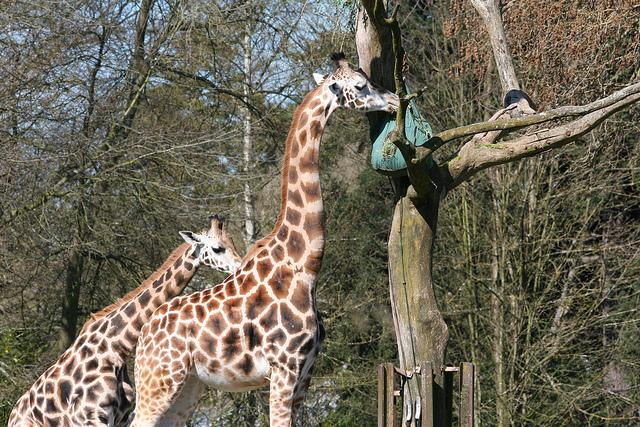What distinguishes the animals above from the rest?

Choices:
A) shortest
B) fastest
C) tallest
D) browsers tallest 